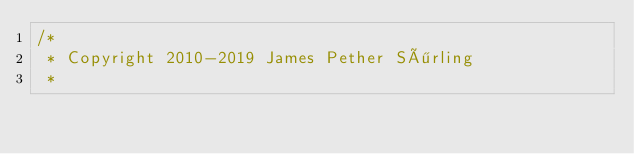<code> <loc_0><loc_0><loc_500><loc_500><_Java_>/*
 * Copyright 2010-2019 James Pether Sörling
 *</code> 